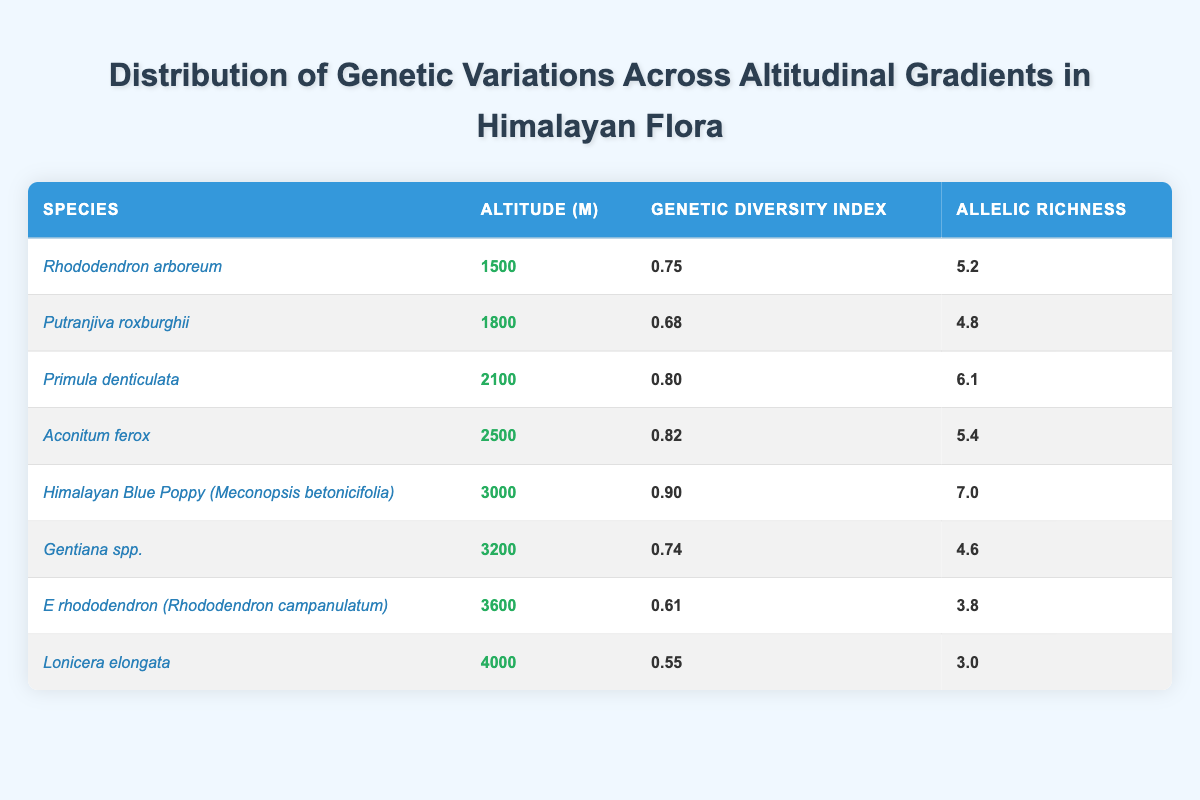What is the genetic diversity index of Himalayan Blue Poppy? The table indicates that the genetic diversity index for Himalayan Blue Poppy (Meconopsis betonicifolia) is 0.90.
Answer: 0.90 Which species has the highest allelic richness? By looking at the table, the species with the highest allelic richness is Himalayan Blue Poppy (Meconopsis betonicifolia) with a value of 7.0.
Answer: 7.0 What is the average genetic diversity index for species below 3000 meters? The species below 3000 meters are Rhododendron arboreum (0.75), Putranjiva roxburghii (0.68), Primula denticulata (0.80), Aconitum ferox (0.82), and Himalayan Blue Poppy (0.90). Summing these values gives 0.75 + 0.68 + 0.80 + 0.82 + 0.90 = 3.95. Then, dividing by the number of species (5), the average is 3.95 / 5 = 0.79.
Answer: 0.79 Is the genetic diversity index of Lonicera elongata higher than that of Rhododendron campanulatum? The genetic diversity index for Lonicera elongata is 0.55, while for Rhododendron campanulatum, it is 0.61. Since 0.55 is not higher than 0.61, the answer is no.
Answer: No What is the difference in allelic richness between the species at 2500m and 4000m? The allelic richness at 2500m (Aconitum ferox) is 5.4, while at 4000m (Lonicera elongata) it is 3.0. The difference is 5.4 - 3.0 = 2.4.
Answer: 2.4 What is the genetic diversity index of the species located at the highest altitude? According to the table, Lonicera elongata is the only species listed at 4000 meters, and its genetic diversity index is 0.55.
Answer: 0.55 How many species have a genetic diversity index above 0.70? Analyzing the table, the species with a genetic diversity index above 0.70 are Rhododendron arboreum (0.75), Primula denticulata (0.80), Aconitum ferox (0.82), and Himalayan Blue Poppy (0.90). This totals four species.
Answer: 4 Is it true that all species at altitudes above 3000 meters have a genetic diversity index above 0.70? From the table, the species above 3000 meters are Himalayan Blue Poppy (0.90), Gentiana spp. (0.74), E rhododendron (0.61), and Lonicera elongata (0.55). Since E rhododendron and Lonicera elongata both have indices below 0.70, the statement is false.
Answer: No 